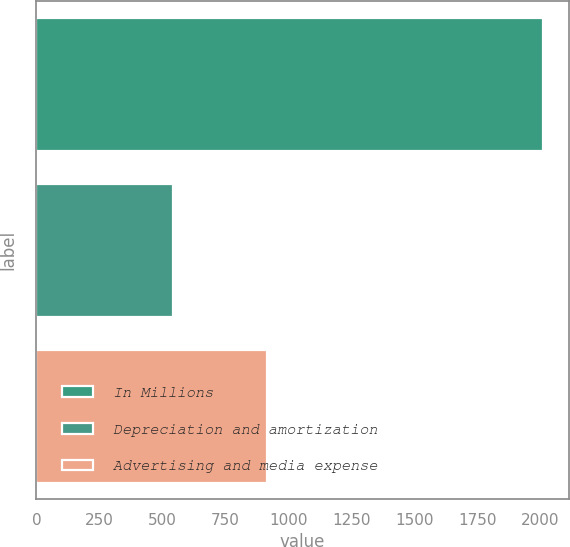<chart> <loc_0><loc_0><loc_500><loc_500><bar_chart><fcel>In Millions<fcel>Depreciation and amortization<fcel>Advertising and media expense<nl><fcel>2012<fcel>541.5<fcel>913.7<nl></chart> 